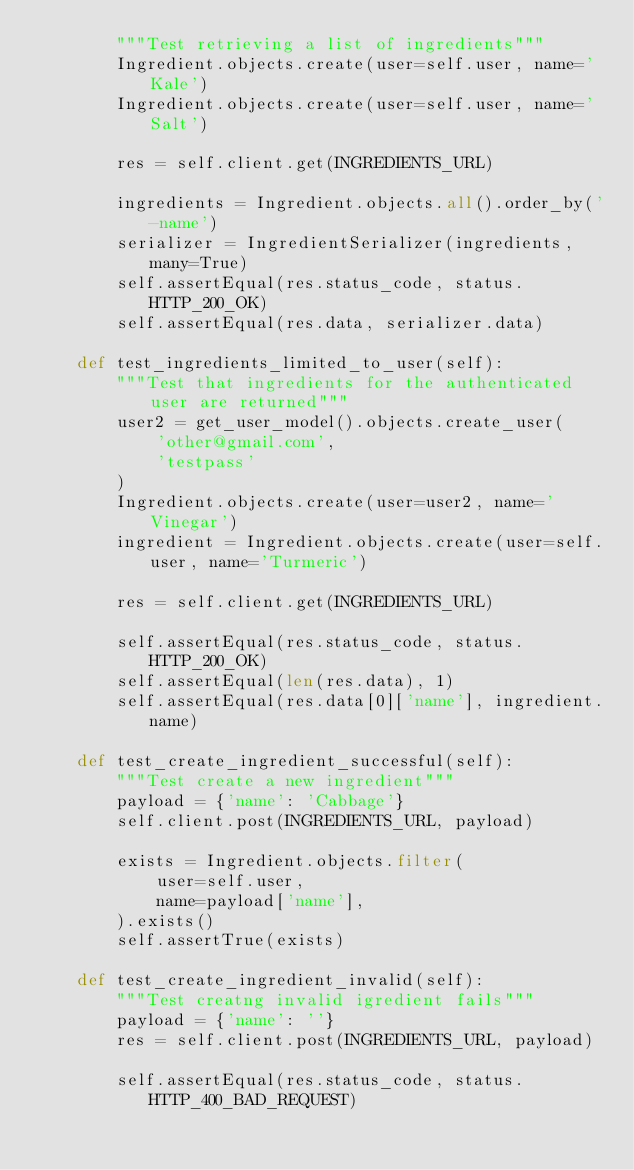Convert code to text. <code><loc_0><loc_0><loc_500><loc_500><_Python_>        """Test retrieving a list of ingredients"""
        Ingredient.objects.create(user=self.user, name='Kale')
        Ingredient.objects.create(user=self.user, name='Salt')

        res = self.client.get(INGREDIENTS_URL)

        ingredients = Ingredient.objects.all().order_by('-name')
        serializer = IngredientSerializer(ingredients, many=True)
        self.assertEqual(res.status_code, status.HTTP_200_OK)
        self.assertEqual(res.data, serializer.data)

    def test_ingredients_limited_to_user(self):
        """Test that ingredients for the authenticated user are returned"""
        user2 = get_user_model().objects.create_user(
            'other@gmail.com',
            'testpass'
        )
        Ingredient.objects.create(user=user2, name='Vinegar')
        ingredient = Ingredient.objects.create(user=self.user, name='Turmeric')

        res = self.client.get(INGREDIENTS_URL)

        self.assertEqual(res.status_code, status.HTTP_200_OK)
        self.assertEqual(len(res.data), 1)
        self.assertEqual(res.data[0]['name'], ingredient.name)

    def test_create_ingredient_successful(self):
        """Test create a new ingredient"""
        payload = {'name': 'Cabbage'}
        self.client.post(INGREDIENTS_URL, payload)

        exists = Ingredient.objects.filter(
            user=self.user,
            name=payload['name'],
        ).exists()
        self.assertTrue(exists)

    def test_create_ingredient_invalid(self):
        """Test creatng invalid igredient fails"""
        payload = {'name': ''}
        res = self.client.post(INGREDIENTS_URL, payload)

        self.assertEqual(res.status_code, status.HTTP_400_BAD_REQUEST)
</code> 